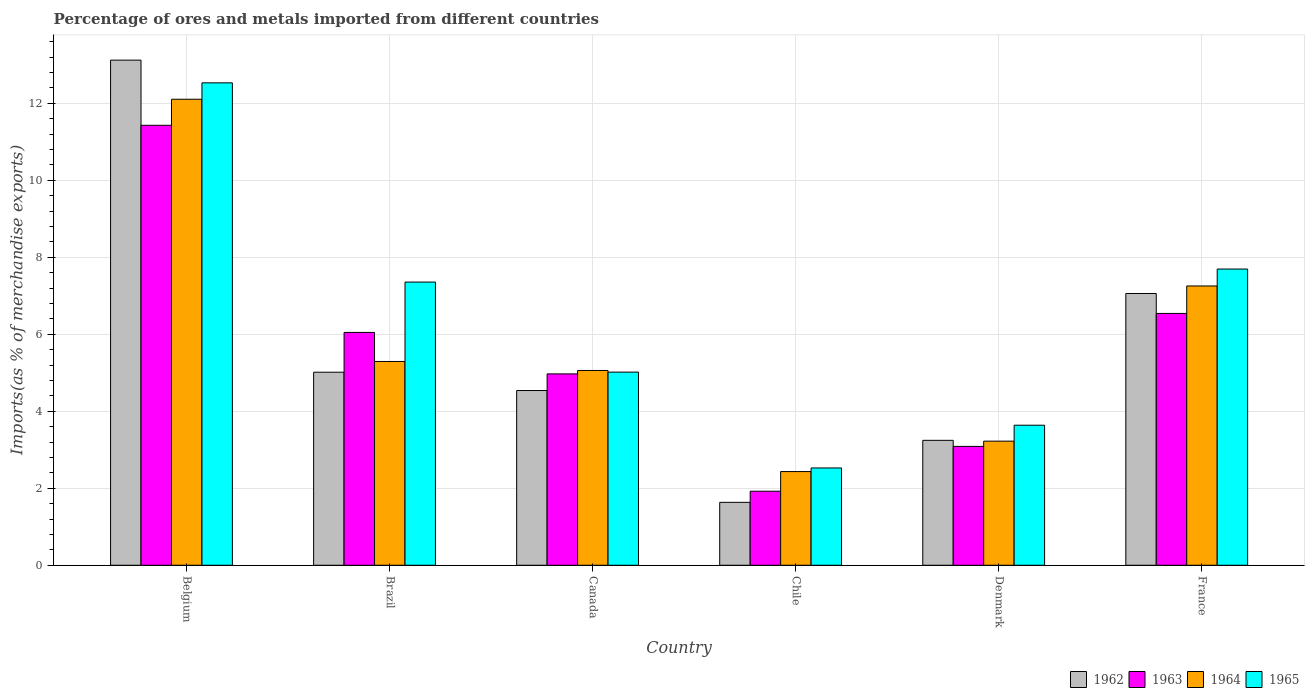How many different coloured bars are there?
Keep it short and to the point. 4. How many groups of bars are there?
Provide a succinct answer. 6. Are the number of bars on each tick of the X-axis equal?
Provide a succinct answer. Yes. How many bars are there on the 6th tick from the left?
Keep it short and to the point. 4. How many bars are there on the 1st tick from the right?
Offer a terse response. 4. What is the percentage of imports to different countries in 1964 in Canada?
Keep it short and to the point. 5.06. Across all countries, what is the maximum percentage of imports to different countries in 1962?
Provide a succinct answer. 13.12. Across all countries, what is the minimum percentage of imports to different countries in 1963?
Ensure brevity in your answer.  1.92. In which country was the percentage of imports to different countries in 1962 minimum?
Your answer should be very brief. Chile. What is the total percentage of imports to different countries in 1963 in the graph?
Keep it short and to the point. 34. What is the difference between the percentage of imports to different countries in 1964 in Brazil and that in France?
Your answer should be compact. -1.96. What is the difference between the percentage of imports to different countries in 1964 in France and the percentage of imports to different countries in 1963 in Chile?
Ensure brevity in your answer.  5.33. What is the average percentage of imports to different countries in 1963 per country?
Provide a short and direct response. 5.67. What is the difference between the percentage of imports to different countries of/in 1963 and percentage of imports to different countries of/in 1965 in Brazil?
Offer a very short reply. -1.31. In how many countries, is the percentage of imports to different countries in 1962 greater than 1.6 %?
Provide a short and direct response. 6. What is the ratio of the percentage of imports to different countries in 1964 in Belgium to that in Denmark?
Your answer should be compact. 3.75. Is the percentage of imports to different countries in 1962 in Belgium less than that in France?
Provide a succinct answer. No. What is the difference between the highest and the second highest percentage of imports to different countries in 1962?
Provide a succinct answer. -8.11. What is the difference between the highest and the lowest percentage of imports to different countries in 1965?
Make the answer very short. 10. In how many countries, is the percentage of imports to different countries in 1965 greater than the average percentage of imports to different countries in 1965 taken over all countries?
Ensure brevity in your answer.  3. Is it the case that in every country, the sum of the percentage of imports to different countries in 1963 and percentage of imports to different countries in 1962 is greater than the sum of percentage of imports to different countries in 1964 and percentage of imports to different countries in 1965?
Provide a short and direct response. No. What does the 1st bar from the left in Chile represents?
Your answer should be very brief. 1962. What does the 1st bar from the right in Chile represents?
Your answer should be very brief. 1965. Is it the case that in every country, the sum of the percentage of imports to different countries in 1964 and percentage of imports to different countries in 1965 is greater than the percentage of imports to different countries in 1962?
Give a very brief answer. Yes. How many bars are there?
Your answer should be compact. 24. How many countries are there in the graph?
Offer a terse response. 6. What is the difference between two consecutive major ticks on the Y-axis?
Offer a very short reply. 2. Does the graph contain any zero values?
Offer a very short reply. No. Does the graph contain grids?
Your answer should be compact. Yes. Where does the legend appear in the graph?
Offer a terse response. Bottom right. How many legend labels are there?
Ensure brevity in your answer.  4. What is the title of the graph?
Give a very brief answer. Percentage of ores and metals imported from different countries. Does "1986" appear as one of the legend labels in the graph?
Your response must be concise. No. What is the label or title of the X-axis?
Offer a terse response. Country. What is the label or title of the Y-axis?
Offer a very short reply. Imports(as % of merchandise exports). What is the Imports(as % of merchandise exports) of 1962 in Belgium?
Offer a very short reply. 13.12. What is the Imports(as % of merchandise exports) in 1963 in Belgium?
Your response must be concise. 11.43. What is the Imports(as % of merchandise exports) of 1964 in Belgium?
Your answer should be compact. 12.11. What is the Imports(as % of merchandise exports) in 1965 in Belgium?
Make the answer very short. 12.53. What is the Imports(as % of merchandise exports) of 1962 in Brazil?
Provide a short and direct response. 5.01. What is the Imports(as % of merchandise exports) of 1963 in Brazil?
Provide a succinct answer. 6.05. What is the Imports(as % of merchandise exports) in 1964 in Brazil?
Ensure brevity in your answer.  5.29. What is the Imports(as % of merchandise exports) of 1965 in Brazil?
Provide a succinct answer. 7.36. What is the Imports(as % of merchandise exports) of 1962 in Canada?
Your response must be concise. 4.54. What is the Imports(as % of merchandise exports) in 1963 in Canada?
Keep it short and to the point. 4.97. What is the Imports(as % of merchandise exports) in 1964 in Canada?
Your answer should be very brief. 5.06. What is the Imports(as % of merchandise exports) of 1965 in Canada?
Make the answer very short. 5.02. What is the Imports(as % of merchandise exports) in 1962 in Chile?
Your response must be concise. 1.63. What is the Imports(as % of merchandise exports) in 1963 in Chile?
Your answer should be very brief. 1.92. What is the Imports(as % of merchandise exports) of 1964 in Chile?
Ensure brevity in your answer.  2.43. What is the Imports(as % of merchandise exports) of 1965 in Chile?
Your response must be concise. 2.53. What is the Imports(as % of merchandise exports) in 1962 in Denmark?
Ensure brevity in your answer.  3.25. What is the Imports(as % of merchandise exports) of 1963 in Denmark?
Provide a succinct answer. 3.09. What is the Imports(as % of merchandise exports) in 1964 in Denmark?
Offer a terse response. 3.22. What is the Imports(as % of merchandise exports) in 1965 in Denmark?
Offer a terse response. 3.64. What is the Imports(as % of merchandise exports) of 1962 in France?
Make the answer very short. 7.06. What is the Imports(as % of merchandise exports) in 1963 in France?
Make the answer very short. 6.54. What is the Imports(as % of merchandise exports) of 1964 in France?
Give a very brief answer. 7.26. What is the Imports(as % of merchandise exports) in 1965 in France?
Your response must be concise. 7.7. Across all countries, what is the maximum Imports(as % of merchandise exports) in 1962?
Make the answer very short. 13.12. Across all countries, what is the maximum Imports(as % of merchandise exports) in 1963?
Provide a succinct answer. 11.43. Across all countries, what is the maximum Imports(as % of merchandise exports) in 1964?
Ensure brevity in your answer.  12.11. Across all countries, what is the maximum Imports(as % of merchandise exports) of 1965?
Provide a short and direct response. 12.53. Across all countries, what is the minimum Imports(as % of merchandise exports) of 1962?
Ensure brevity in your answer.  1.63. Across all countries, what is the minimum Imports(as % of merchandise exports) in 1963?
Give a very brief answer. 1.92. Across all countries, what is the minimum Imports(as % of merchandise exports) in 1964?
Provide a succinct answer. 2.43. Across all countries, what is the minimum Imports(as % of merchandise exports) of 1965?
Your answer should be compact. 2.53. What is the total Imports(as % of merchandise exports) of 1962 in the graph?
Keep it short and to the point. 34.62. What is the total Imports(as % of merchandise exports) in 1963 in the graph?
Give a very brief answer. 34. What is the total Imports(as % of merchandise exports) of 1964 in the graph?
Your answer should be compact. 35.37. What is the total Imports(as % of merchandise exports) in 1965 in the graph?
Keep it short and to the point. 38.77. What is the difference between the Imports(as % of merchandise exports) of 1962 in Belgium and that in Brazil?
Provide a short and direct response. 8.11. What is the difference between the Imports(as % of merchandise exports) of 1963 in Belgium and that in Brazil?
Your answer should be very brief. 5.38. What is the difference between the Imports(as % of merchandise exports) of 1964 in Belgium and that in Brazil?
Give a very brief answer. 6.81. What is the difference between the Imports(as % of merchandise exports) in 1965 in Belgium and that in Brazil?
Give a very brief answer. 5.18. What is the difference between the Imports(as % of merchandise exports) in 1962 in Belgium and that in Canada?
Your answer should be compact. 8.58. What is the difference between the Imports(as % of merchandise exports) of 1963 in Belgium and that in Canada?
Ensure brevity in your answer.  6.46. What is the difference between the Imports(as % of merchandise exports) of 1964 in Belgium and that in Canada?
Provide a short and direct response. 7.05. What is the difference between the Imports(as % of merchandise exports) of 1965 in Belgium and that in Canada?
Provide a short and direct response. 7.51. What is the difference between the Imports(as % of merchandise exports) in 1962 in Belgium and that in Chile?
Offer a terse response. 11.49. What is the difference between the Imports(as % of merchandise exports) in 1963 in Belgium and that in Chile?
Provide a succinct answer. 9.51. What is the difference between the Imports(as % of merchandise exports) of 1964 in Belgium and that in Chile?
Give a very brief answer. 9.67. What is the difference between the Imports(as % of merchandise exports) in 1965 in Belgium and that in Chile?
Keep it short and to the point. 10. What is the difference between the Imports(as % of merchandise exports) in 1962 in Belgium and that in Denmark?
Ensure brevity in your answer.  9.88. What is the difference between the Imports(as % of merchandise exports) of 1963 in Belgium and that in Denmark?
Provide a short and direct response. 8.34. What is the difference between the Imports(as % of merchandise exports) in 1964 in Belgium and that in Denmark?
Your response must be concise. 8.88. What is the difference between the Imports(as % of merchandise exports) in 1965 in Belgium and that in Denmark?
Your answer should be very brief. 8.89. What is the difference between the Imports(as % of merchandise exports) in 1962 in Belgium and that in France?
Offer a terse response. 6.06. What is the difference between the Imports(as % of merchandise exports) in 1963 in Belgium and that in France?
Give a very brief answer. 4.89. What is the difference between the Imports(as % of merchandise exports) of 1964 in Belgium and that in France?
Give a very brief answer. 4.85. What is the difference between the Imports(as % of merchandise exports) in 1965 in Belgium and that in France?
Your answer should be very brief. 4.84. What is the difference between the Imports(as % of merchandise exports) in 1962 in Brazil and that in Canada?
Keep it short and to the point. 0.48. What is the difference between the Imports(as % of merchandise exports) in 1963 in Brazil and that in Canada?
Provide a short and direct response. 1.08. What is the difference between the Imports(as % of merchandise exports) in 1964 in Brazil and that in Canada?
Provide a succinct answer. 0.23. What is the difference between the Imports(as % of merchandise exports) of 1965 in Brazil and that in Canada?
Keep it short and to the point. 2.34. What is the difference between the Imports(as % of merchandise exports) of 1962 in Brazil and that in Chile?
Provide a short and direct response. 3.38. What is the difference between the Imports(as % of merchandise exports) in 1963 in Brazil and that in Chile?
Make the answer very short. 4.12. What is the difference between the Imports(as % of merchandise exports) of 1964 in Brazil and that in Chile?
Provide a short and direct response. 2.86. What is the difference between the Imports(as % of merchandise exports) of 1965 in Brazil and that in Chile?
Make the answer very short. 4.83. What is the difference between the Imports(as % of merchandise exports) in 1962 in Brazil and that in Denmark?
Ensure brevity in your answer.  1.77. What is the difference between the Imports(as % of merchandise exports) of 1963 in Brazil and that in Denmark?
Keep it short and to the point. 2.96. What is the difference between the Imports(as % of merchandise exports) in 1964 in Brazil and that in Denmark?
Give a very brief answer. 2.07. What is the difference between the Imports(as % of merchandise exports) in 1965 in Brazil and that in Denmark?
Give a very brief answer. 3.72. What is the difference between the Imports(as % of merchandise exports) in 1962 in Brazil and that in France?
Keep it short and to the point. -2.05. What is the difference between the Imports(as % of merchandise exports) in 1963 in Brazil and that in France?
Offer a very short reply. -0.49. What is the difference between the Imports(as % of merchandise exports) in 1964 in Brazil and that in France?
Your answer should be very brief. -1.96. What is the difference between the Imports(as % of merchandise exports) in 1965 in Brazil and that in France?
Your answer should be compact. -0.34. What is the difference between the Imports(as % of merchandise exports) of 1962 in Canada and that in Chile?
Provide a short and direct response. 2.9. What is the difference between the Imports(as % of merchandise exports) of 1963 in Canada and that in Chile?
Provide a succinct answer. 3.05. What is the difference between the Imports(as % of merchandise exports) of 1964 in Canada and that in Chile?
Your answer should be very brief. 2.63. What is the difference between the Imports(as % of merchandise exports) of 1965 in Canada and that in Chile?
Ensure brevity in your answer.  2.49. What is the difference between the Imports(as % of merchandise exports) of 1962 in Canada and that in Denmark?
Your answer should be very brief. 1.29. What is the difference between the Imports(as % of merchandise exports) in 1963 in Canada and that in Denmark?
Provide a succinct answer. 1.88. What is the difference between the Imports(as % of merchandise exports) of 1964 in Canada and that in Denmark?
Offer a very short reply. 1.84. What is the difference between the Imports(as % of merchandise exports) of 1965 in Canada and that in Denmark?
Provide a succinct answer. 1.38. What is the difference between the Imports(as % of merchandise exports) of 1962 in Canada and that in France?
Provide a short and direct response. -2.52. What is the difference between the Imports(as % of merchandise exports) of 1963 in Canada and that in France?
Keep it short and to the point. -1.57. What is the difference between the Imports(as % of merchandise exports) of 1964 in Canada and that in France?
Your response must be concise. -2.19. What is the difference between the Imports(as % of merchandise exports) in 1965 in Canada and that in France?
Give a very brief answer. -2.68. What is the difference between the Imports(as % of merchandise exports) of 1962 in Chile and that in Denmark?
Keep it short and to the point. -1.61. What is the difference between the Imports(as % of merchandise exports) in 1963 in Chile and that in Denmark?
Offer a very short reply. -1.16. What is the difference between the Imports(as % of merchandise exports) of 1964 in Chile and that in Denmark?
Your answer should be compact. -0.79. What is the difference between the Imports(as % of merchandise exports) of 1965 in Chile and that in Denmark?
Keep it short and to the point. -1.11. What is the difference between the Imports(as % of merchandise exports) of 1962 in Chile and that in France?
Ensure brevity in your answer.  -5.43. What is the difference between the Imports(as % of merchandise exports) in 1963 in Chile and that in France?
Provide a succinct answer. -4.62. What is the difference between the Imports(as % of merchandise exports) of 1964 in Chile and that in France?
Offer a terse response. -4.82. What is the difference between the Imports(as % of merchandise exports) of 1965 in Chile and that in France?
Your response must be concise. -5.17. What is the difference between the Imports(as % of merchandise exports) of 1962 in Denmark and that in France?
Your answer should be very brief. -3.81. What is the difference between the Imports(as % of merchandise exports) in 1963 in Denmark and that in France?
Make the answer very short. -3.45. What is the difference between the Imports(as % of merchandise exports) in 1964 in Denmark and that in France?
Make the answer very short. -4.03. What is the difference between the Imports(as % of merchandise exports) of 1965 in Denmark and that in France?
Your answer should be very brief. -4.06. What is the difference between the Imports(as % of merchandise exports) of 1962 in Belgium and the Imports(as % of merchandise exports) of 1963 in Brazil?
Ensure brevity in your answer.  7.07. What is the difference between the Imports(as % of merchandise exports) of 1962 in Belgium and the Imports(as % of merchandise exports) of 1964 in Brazil?
Give a very brief answer. 7.83. What is the difference between the Imports(as % of merchandise exports) of 1962 in Belgium and the Imports(as % of merchandise exports) of 1965 in Brazil?
Make the answer very short. 5.77. What is the difference between the Imports(as % of merchandise exports) in 1963 in Belgium and the Imports(as % of merchandise exports) in 1964 in Brazil?
Your answer should be compact. 6.14. What is the difference between the Imports(as % of merchandise exports) in 1963 in Belgium and the Imports(as % of merchandise exports) in 1965 in Brazil?
Make the answer very short. 4.07. What is the difference between the Imports(as % of merchandise exports) of 1964 in Belgium and the Imports(as % of merchandise exports) of 1965 in Brazil?
Make the answer very short. 4.75. What is the difference between the Imports(as % of merchandise exports) of 1962 in Belgium and the Imports(as % of merchandise exports) of 1963 in Canada?
Your response must be concise. 8.15. What is the difference between the Imports(as % of merchandise exports) in 1962 in Belgium and the Imports(as % of merchandise exports) in 1964 in Canada?
Provide a succinct answer. 8.06. What is the difference between the Imports(as % of merchandise exports) of 1962 in Belgium and the Imports(as % of merchandise exports) of 1965 in Canada?
Ensure brevity in your answer.  8.1. What is the difference between the Imports(as % of merchandise exports) of 1963 in Belgium and the Imports(as % of merchandise exports) of 1964 in Canada?
Provide a short and direct response. 6.37. What is the difference between the Imports(as % of merchandise exports) in 1963 in Belgium and the Imports(as % of merchandise exports) in 1965 in Canada?
Your response must be concise. 6.41. What is the difference between the Imports(as % of merchandise exports) of 1964 in Belgium and the Imports(as % of merchandise exports) of 1965 in Canada?
Keep it short and to the point. 7.09. What is the difference between the Imports(as % of merchandise exports) in 1962 in Belgium and the Imports(as % of merchandise exports) in 1963 in Chile?
Make the answer very short. 11.2. What is the difference between the Imports(as % of merchandise exports) of 1962 in Belgium and the Imports(as % of merchandise exports) of 1964 in Chile?
Your answer should be very brief. 10.69. What is the difference between the Imports(as % of merchandise exports) of 1962 in Belgium and the Imports(as % of merchandise exports) of 1965 in Chile?
Give a very brief answer. 10.59. What is the difference between the Imports(as % of merchandise exports) in 1963 in Belgium and the Imports(as % of merchandise exports) in 1964 in Chile?
Ensure brevity in your answer.  9. What is the difference between the Imports(as % of merchandise exports) in 1963 in Belgium and the Imports(as % of merchandise exports) in 1965 in Chile?
Provide a succinct answer. 8.9. What is the difference between the Imports(as % of merchandise exports) of 1964 in Belgium and the Imports(as % of merchandise exports) of 1965 in Chile?
Your response must be concise. 9.58. What is the difference between the Imports(as % of merchandise exports) in 1962 in Belgium and the Imports(as % of merchandise exports) in 1963 in Denmark?
Your response must be concise. 10.03. What is the difference between the Imports(as % of merchandise exports) of 1962 in Belgium and the Imports(as % of merchandise exports) of 1964 in Denmark?
Provide a succinct answer. 9.9. What is the difference between the Imports(as % of merchandise exports) in 1962 in Belgium and the Imports(as % of merchandise exports) in 1965 in Denmark?
Give a very brief answer. 9.48. What is the difference between the Imports(as % of merchandise exports) of 1963 in Belgium and the Imports(as % of merchandise exports) of 1964 in Denmark?
Give a very brief answer. 8.21. What is the difference between the Imports(as % of merchandise exports) of 1963 in Belgium and the Imports(as % of merchandise exports) of 1965 in Denmark?
Offer a terse response. 7.79. What is the difference between the Imports(as % of merchandise exports) of 1964 in Belgium and the Imports(as % of merchandise exports) of 1965 in Denmark?
Your response must be concise. 8.47. What is the difference between the Imports(as % of merchandise exports) of 1962 in Belgium and the Imports(as % of merchandise exports) of 1963 in France?
Ensure brevity in your answer.  6.58. What is the difference between the Imports(as % of merchandise exports) in 1962 in Belgium and the Imports(as % of merchandise exports) in 1964 in France?
Give a very brief answer. 5.87. What is the difference between the Imports(as % of merchandise exports) of 1962 in Belgium and the Imports(as % of merchandise exports) of 1965 in France?
Make the answer very short. 5.43. What is the difference between the Imports(as % of merchandise exports) of 1963 in Belgium and the Imports(as % of merchandise exports) of 1964 in France?
Ensure brevity in your answer.  4.17. What is the difference between the Imports(as % of merchandise exports) of 1963 in Belgium and the Imports(as % of merchandise exports) of 1965 in France?
Ensure brevity in your answer.  3.73. What is the difference between the Imports(as % of merchandise exports) of 1964 in Belgium and the Imports(as % of merchandise exports) of 1965 in France?
Keep it short and to the point. 4.41. What is the difference between the Imports(as % of merchandise exports) in 1962 in Brazil and the Imports(as % of merchandise exports) in 1963 in Canada?
Ensure brevity in your answer.  0.04. What is the difference between the Imports(as % of merchandise exports) of 1962 in Brazil and the Imports(as % of merchandise exports) of 1964 in Canada?
Offer a very short reply. -0.05. What is the difference between the Imports(as % of merchandise exports) in 1962 in Brazil and the Imports(as % of merchandise exports) in 1965 in Canada?
Make the answer very short. -0. What is the difference between the Imports(as % of merchandise exports) in 1963 in Brazil and the Imports(as % of merchandise exports) in 1964 in Canada?
Your response must be concise. 0.99. What is the difference between the Imports(as % of merchandise exports) of 1963 in Brazil and the Imports(as % of merchandise exports) of 1965 in Canada?
Provide a short and direct response. 1.03. What is the difference between the Imports(as % of merchandise exports) of 1964 in Brazil and the Imports(as % of merchandise exports) of 1965 in Canada?
Your answer should be very brief. 0.28. What is the difference between the Imports(as % of merchandise exports) in 1962 in Brazil and the Imports(as % of merchandise exports) in 1963 in Chile?
Ensure brevity in your answer.  3.09. What is the difference between the Imports(as % of merchandise exports) of 1962 in Brazil and the Imports(as % of merchandise exports) of 1964 in Chile?
Ensure brevity in your answer.  2.58. What is the difference between the Imports(as % of merchandise exports) of 1962 in Brazil and the Imports(as % of merchandise exports) of 1965 in Chile?
Offer a very short reply. 2.49. What is the difference between the Imports(as % of merchandise exports) in 1963 in Brazil and the Imports(as % of merchandise exports) in 1964 in Chile?
Your response must be concise. 3.61. What is the difference between the Imports(as % of merchandise exports) of 1963 in Brazil and the Imports(as % of merchandise exports) of 1965 in Chile?
Provide a succinct answer. 3.52. What is the difference between the Imports(as % of merchandise exports) in 1964 in Brazil and the Imports(as % of merchandise exports) in 1965 in Chile?
Give a very brief answer. 2.77. What is the difference between the Imports(as % of merchandise exports) in 1962 in Brazil and the Imports(as % of merchandise exports) in 1963 in Denmark?
Make the answer very short. 1.93. What is the difference between the Imports(as % of merchandise exports) of 1962 in Brazil and the Imports(as % of merchandise exports) of 1964 in Denmark?
Your answer should be very brief. 1.79. What is the difference between the Imports(as % of merchandise exports) of 1962 in Brazil and the Imports(as % of merchandise exports) of 1965 in Denmark?
Keep it short and to the point. 1.38. What is the difference between the Imports(as % of merchandise exports) in 1963 in Brazil and the Imports(as % of merchandise exports) in 1964 in Denmark?
Your answer should be compact. 2.82. What is the difference between the Imports(as % of merchandise exports) in 1963 in Brazil and the Imports(as % of merchandise exports) in 1965 in Denmark?
Keep it short and to the point. 2.41. What is the difference between the Imports(as % of merchandise exports) in 1964 in Brazil and the Imports(as % of merchandise exports) in 1965 in Denmark?
Your answer should be compact. 1.66. What is the difference between the Imports(as % of merchandise exports) in 1962 in Brazil and the Imports(as % of merchandise exports) in 1963 in France?
Give a very brief answer. -1.53. What is the difference between the Imports(as % of merchandise exports) of 1962 in Brazil and the Imports(as % of merchandise exports) of 1964 in France?
Your answer should be very brief. -2.24. What is the difference between the Imports(as % of merchandise exports) of 1962 in Brazil and the Imports(as % of merchandise exports) of 1965 in France?
Offer a terse response. -2.68. What is the difference between the Imports(as % of merchandise exports) of 1963 in Brazil and the Imports(as % of merchandise exports) of 1964 in France?
Make the answer very short. -1.21. What is the difference between the Imports(as % of merchandise exports) in 1963 in Brazil and the Imports(as % of merchandise exports) in 1965 in France?
Provide a succinct answer. -1.65. What is the difference between the Imports(as % of merchandise exports) of 1964 in Brazil and the Imports(as % of merchandise exports) of 1965 in France?
Provide a succinct answer. -2.4. What is the difference between the Imports(as % of merchandise exports) in 1962 in Canada and the Imports(as % of merchandise exports) in 1963 in Chile?
Give a very brief answer. 2.62. What is the difference between the Imports(as % of merchandise exports) in 1962 in Canada and the Imports(as % of merchandise exports) in 1964 in Chile?
Make the answer very short. 2.11. What is the difference between the Imports(as % of merchandise exports) in 1962 in Canada and the Imports(as % of merchandise exports) in 1965 in Chile?
Your answer should be very brief. 2.01. What is the difference between the Imports(as % of merchandise exports) in 1963 in Canada and the Imports(as % of merchandise exports) in 1964 in Chile?
Provide a short and direct response. 2.54. What is the difference between the Imports(as % of merchandise exports) of 1963 in Canada and the Imports(as % of merchandise exports) of 1965 in Chile?
Ensure brevity in your answer.  2.44. What is the difference between the Imports(as % of merchandise exports) of 1964 in Canada and the Imports(as % of merchandise exports) of 1965 in Chile?
Your response must be concise. 2.53. What is the difference between the Imports(as % of merchandise exports) of 1962 in Canada and the Imports(as % of merchandise exports) of 1963 in Denmark?
Your answer should be compact. 1.45. What is the difference between the Imports(as % of merchandise exports) of 1962 in Canada and the Imports(as % of merchandise exports) of 1964 in Denmark?
Your response must be concise. 1.31. What is the difference between the Imports(as % of merchandise exports) of 1962 in Canada and the Imports(as % of merchandise exports) of 1965 in Denmark?
Your response must be concise. 0.9. What is the difference between the Imports(as % of merchandise exports) of 1963 in Canada and the Imports(as % of merchandise exports) of 1964 in Denmark?
Provide a succinct answer. 1.75. What is the difference between the Imports(as % of merchandise exports) of 1963 in Canada and the Imports(as % of merchandise exports) of 1965 in Denmark?
Make the answer very short. 1.33. What is the difference between the Imports(as % of merchandise exports) in 1964 in Canada and the Imports(as % of merchandise exports) in 1965 in Denmark?
Keep it short and to the point. 1.42. What is the difference between the Imports(as % of merchandise exports) of 1962 in Canada and the Imports(as % of merchandise exports) of 1963 in France?
Ensure brevity in your answer.  -2. What is the difference between the Imports(as % of merchandise exports) in 1962 in Canada and the Imports(as % of merchandise exports) in 1964 in France?
Your answer should be compact. -2.72. What is the difference between the Imports(as % of merchandise exports) in 1962 in Canada and the Imports(as % of merchandise exports) in 1965 in France?
Your answer should be compact. -3.16. What is the difference between the Imports(as % of merchandise exports) of 1963 in Canada and the Imports(as % of merchandise exports) of 1964 in France?
Your answer should be compact. -2.28. What is the difference between the Imports(as % of merchandise exports) in 1963 in Canada and the Imports(as % of merchandise exports) in 1965 in France?
Keep it short and to the point. -2.72. What is the difference between the Imports(as % of merchandise exports) of 1964 in Canada and the Imports(as % of merchandise exports) of 1965 in France?
Your response must be concise. -2.64. What is the difference between the Imports(as % of merchandise exports) in 1962 in Chile and the Imports(as % of merchandise exports) in 1963 in Denmark?
Ensure brevity in your answer.  -1.45. What is the difference between the Imports(as % of merchandise exports) of 1962 in Chile and the Imports(as % of merchandise exports) of 1964 in Denmark?
Ensure brevity in your answer.  -1.59. What is the difference between the Imports(as % of merchandise exports) in 1962 in Chile and the Imports(as % of merchandise exports) in 1965 in Denmark?
Your answer should be very brief. -2. What is the difference between the Imports(as % of merchandise exports) in 1963 in Chile and the Imports(as % of merchandise exports) in 1964 in Denmark?
Keep it short and to the point. -1.3. What is the difference between the Imports(as % of merchandise exports) of 1963 in Chile and the Imports(as % of merchandise exports) of 1965 in Denmark?
Offer a very short reply. -1.71. What is the difference between the Imports(as % of merchandise exports) in 1964 in Chile and the Imports(as % of merchandise exports) in 1965 in Denmark?
Give a very brief answer. -1.2. What is the difference between the Imports(as % of merchandise exports) of 1962 in Chile and the Imports(as % of merchandise exports) of 1963 in France?
Make the answer very short. -4.91. What is the difference between the Imports(as % of merchandise exports) in 1962 in Chile and the Imports(as % of merchandise exports) in 1964 in France?
Provide a short and direct response. -5.62. What is the difference between the Imports(as % of merchandise exports) in 1962 in Chile and the Imports(as % of merchandise exports) in 1965 in France?
Keep it short and to the point. -6.06. What is the difference between the Imports(as % of merchandise exports) of 1963 in Chile and the Imports(as % of merchandise exports) of 1964 in France?
Your answer should be very brief. -5.33. What is the difference between the Imports(as % of merchandise exports) in 1963 in Chile and the Imports(as % of merchandise exports) in 1965 in France?
Your answer should be very brief. -5.77. What is the difference between the Imports(as % of merchandise exports) in 1964 in Chile and the Imports(as % of merchandise exports) in 1965 in France?
Your response must be concise. -5.26. What is the difference between the Imports(as % of merchandise exports) in 1962 in Denmark and the Imports(as % of merchandise exports) in 1963 in France?
Make the answer very short. -3.3. What is the difference between the Imports(as % of merchandise exports) of 1962 in Denmark and the Imports(as % of merchandise exports) of 1964 in France?
Give a very brief answer. -4.01. What is the difference between the Imports(as % of merchandise exports) of 1962 in Denmark and the Imports(as % of merchandise exports) of 1965 in France?
Provide a succinct answer. -4.45. What is the difference between the Imports(as % of merchandise exports) in 1963 in Denmark and the Imports(as % of merchandise exports) in 1964 in France?
Give a very brief answer. -4.17. What is the difference between the Imports(as % of merchandise exports) in 1963 in Denmark and the Imports(as % of merchandise exports) in 1965 in France?
Your response must be concise. -4.61. What is the difference between the Imports(as % of merchandise exports) of 1964 in Denmark and the Imports(as % of merchandise exports) of 1965 in France?
Your answer should be compact. -4.47. What is the average Imports(as % of merchandise exports) of 1962 per country?
Offer a very short reply. 5.77. What is the average Imports(as % of merchandise exports) of 1963 per country?
Keep it short and to the point. 5.67. What is the average Imports(as % of merchandise exports) of 1964 per country?
Your answer should be very brief. 5.9. What is the average Imports(as % of merchandise exports) in 1965 per country?
Provide a short and direct response. 6.46. What is the difference between the Imports(as % of merchandise exports) of 1962 and Imports(as % of merchandise exports) of 1963 in Belgium?
Give a very brief answer. 1.69. What is the difference between the Imports(as % of merchandise exports) of 1962 and Imports(as % of merchandise exports) of 1964 in Belgium?
Offer a very short reply. 1.02. What is the difference between the Imports(as % of merchandise exports) in 1962 and Imports(as % of merchandise exports) in 1965 in Belgium?
Offer a terse response. 0.59. What is the difference between the Imports(as % of merchandise exports) of 1963 and Imports(as % of merchandise exports) of 1964 in Belgium?
Ensure brevity in your answer.  -0.68. What is the difference between the Imports(as % of merchandise exports) in 1963 and Imports(as % of merchandise exports) in 1965 in Belgium?
Give a very brief answer. -1.1. What is the difference between the Imports(as % of merchandise exports) in 1964 and Imports(as % of merchandise exports) in 1965 in Belgium?
Your answer should be compact. -0.43. What is the difference between the Imports(as % of merchandise exports) of 1962 and Imports(as % of merchandise exports) of 1963 in Brazil?
Provide a short and direct response. -1.03. What is the difference between the Imports(as % of merchandise exports) of 1962 and Imports(as % of merchandise exports) of 1964 in Brazil?
Your response must be concise. -0.28. What is the difference between the Imports(as % of merchandise exports) of 1962 and Imports(as % of merchandise exports) of 1965 in Brazil?
Keep it short and to the point. -2.34. What is the difference between the Imports(as % of merchandise exports) in 1963 and Imports(as % of merchandise exports) in 1964 in Brazil?
Give a very brief answer. 0.75. What is the difference between the Imports(as % of merchandise exports) of 1963 and Imports(as % of merchandise exports) of 1965 in Brazil?
Offer a terse response. -1.31. What is the difference between the Imports(as % of merchandise exports) in 1964 and Imports(as % of merchandise exports) in 1965 in Brazil?
Offer a terse response. -2.06. What is the difference between the Imports(as % of merchandise exports) of 1962 and Imports(as % of merchandise exports) of 1963 in Canada?
Your answer should be compact. -0.43. What is the difference between the Imports(as % of merchandise exports) in 1962 and Imports(as % of merchandise exports) in 1964 in Canada?
Give a very brief answer. -0.52. What is the difference between the Imports(as % of merchandise exports) of 1962 and Imports(as % of merchandise exports) of 1965 in Canada?
Offer a terse response. -0.48. What is the difference between the Imports(as % of merchandise exports) of 1963 and Imports(as % of merchandise exports) of 1964 in Canada?
Provide a short and direct response. -0.09. What is the difference between the Imports(as % of merchandise exports) in 1963 and Imports(as % of merchandise exports) in 1965 in Canada?
Your answer should be very brief. -0.05. What is the difference between the Imports(as % of merchandise exports) of 1964 and Imports(as % of merchandise exports) of 1965 in Canada?
Your response must be concise. 0.04. What is the difference between the Imports(as % of merchandise exports) of 1962 and Imports(as % of merchandise exports) of 1963 in Chile?
Your answer should be compact. -0.29. What is the difference between the Imports(as % of merchandise exports) in 1962 and Imports(as % of merchandise exports) in 1964 in Chile?
Your answer should be very brief. -0.8. What is the difference between the Imports(as % of merchandise exports) in 1962 and Imports(as % of merchandise exports) in 1965 in Chile?
Make the answer very short. -0.89. What is the difference between the Imports(as % of merchandise exports) of 1963 and Imports(as % of merchandise exports) of 1964 in Chile?
Ensure brevity in your answer.  -0.51. What is the difference between the Imports(as % of merchandise exports) in 1963 and Imports(as % of merchandise exports) in 1965 in Chile?
Make the answer very short. -0.6. What is the difference between the Imports(as % of merchandise exports) in 1964 and Imports(as % of merchandise exports) in 1965 in Chile?
Give a very brief answer. -0.09. What is the difference between the Imports(as % of merchandise exports) in 1962 and Imports(as % of merchandise exports) in 1963 in Denmark?
Offer a terse response. 0.16. What is the difference between the Imports(as % of merchandise exports) of 1962 and Imports(as % of merchandise exports) of 1964 in Denmark?
Ensure brevity in your answer.  0.02. What is the difference between the Imports(as % of merchandise exports) in 1962 and Imports(as % of merchandise exports) in 1965 in Denmark?
Provide a succinct answer. -0.39. What is the difference between the Imports(as % of merchandise exports) of 1963 and Imports(as % of merchandise exports) of 1964 in Denmark?
Provide a short and direct response. -0.14. What is the difference between the Imports(as % of merchandise exports) in 1963 and Imports(as % of merchandise exports) in 1965 in Denmark?
Keep it short and to the point. -0.55. What is the difference between the Imports(as % of merchandise exports) of 1964 and Imports(as % of merchandise exports) of 1965 in Denmark?
Keep it short and to the point. -0.41. What is the difference between the Imports(as % of merchandise exports) of 1962 and Imports(as % of merchandise exports) of 1963 in France?
Your response must be concise. 0.52. What is the difference between the Imports(as % of merchandise exports) of 1962 and Imports(as % of merchandise exports) of 1964 in France?
Your response must be concise. -0.2. What is the difference between the Imports(as % of merchandise exports) in 1962 and Imports(as % of merchandise exports) in 1965 in France?
Make the answer very short. -0.64. What is the difference between the Imports(as % of merchandise exports) of 1963 and Imports(as % of merchandise exports) of 1964 in France?
Your answer should be compact. -0.71. What is the difference between the Imports(as % of merchandise exports) in 1963 and Imports(as % of merchandise exports) in 1965 in France?
Offer a very short reply. -1.15. What is the difference between the Imports(as % of merchandise exports) in 1964 and Imports(as % of merchandise exports) in 1965 in France?
Give a very brief answer. -0.44. What is the ratio of the Imports(as % of merchandise exports) in 1962 in Belgium to that in Brazil?
Your response must be concise. 2.62. What is the ratio of the Imports(as % of merchandise exports) in 1963 in Belgium to that in Brazil?
Ensure brevity in your answer.  1.89. What is the ratio of the Imports(as % of merchandise exports) in 1964 in Belgium to that in Brazil?
Ensure brevity in your answer.  2.29. What is the ratio of the Imports(as % of merchandise exports) of 1965 in Belgium to that in Brazil?
Offer a terse response. 1.7. What is the ratio of the Imports(as % of merchandise exports) in 1962 in Belgium to that in Canada?
Give a very brief answer. 2.89. What is the ratio of the Imports(as % of merchandise exports) of 1963 in Belgium to that in Canada?
Make the answer very short. 2.3. What is the ratio of the Imports(as % of merchandise exports) of 1964 in Belgium to that in Canada?
Ensure brevity in your answer.  2.39. What is the ratio of the Imports(as % of merchandise exports) in 1965 in Belgium to that in Canada?
Your answer should be compact. 2.5. What is the ratio of the Imports(as % of merchandise exports) in 1962 in Belgium to that in Chile?
Offer a very short reply. 8.03. What is the ratio of the Imports(as % of merchandise exports) of 1963 in Belgium to that in Chile?
Provide a short and direct response. 5.94. What is the ratio of the Imports(as % of merchandise exports) of 1964 in Belgium to that in Chile?
Make the answer very short. 4.97. What is the ratio of the Imports(as % of merchandise exports) of 1965 in Belgium to that in Chile?
Provide a succinct answer. 4.96. What is the ratio of the Imports(as % of merchandise exports) in 1962 in Belgium to that in Denmark?
Your answer should be very brief. 4.04. What is the ratio of the Imports(as % of merchandise exports) of 1963 in Belgium to that in Denmark?
Keep it short and to the point. 3.7. What is the ratio of the Imports(as % of merchandise exports) of 1964 in Belgium to that in Denmark?
Provide a succinct answer. 3.75. What is the ratio of the Imports(as % of merchandise exports) in 1965 in Belgium to that in Denmark?
Your answer should be very brief. 3.44. What is the ratio of the Imports(as % of merchandise exports) of 1962 in Belgium to that in France?
Give a very brief answer. 1.86. What is the ratio of the Imports(as % of merchandise exports) of 1963 in Belgium to that in France?
Your answer should be compact. 1.75. What is the ratio of the Imports(as % of merchandise exports) of 1964 in Belgium to that in France?
Ensure brevity in your answer.  1.67. What is the ratio of the Imports(as % of merchandise exports) of 1965 in Belgium to that in France?
Your response must be concise. 1.63. What is the ratio of the Imports(as % of merchandise exports) in 1962 in Brazil to that in Canada?
Give a very brief answer. 1.1. What is the ratio of the Imports(as % of merchandise exports) in 1963 in Brazil to that in Canada?
Provide a succinct answer. 1.22. What is the ratio of the Imports(as % of merchandise exports) of 1964 in Brazil to that in Canada?
Your answer should be very brief. 1.05. What is the ratio of the Imports(as % of merchandise exports) of 1965 in Brazil to that in Canada?
Provide a short and direct response. 1.47. What is the ratio of the Imports(as % of merchandise exports) of 1962 in Brazil to that in Chile?
Offer a very short reply. 3.07. What is the ratio of the Imports(as % of merchandise exports) in 1963 in Brazil to that in Chile?
Give a very brief answer. 3.14. What is the ratio of the Imports(as % of merchandise exports) of 1964 in Brazil to that in Chile?
Provide a succinct answer. 2.18. What is the ratio of the Imports(as % of merchandise exports) of 1965 in Brazil to that in Chile?
Ensure brevity in your answer.  2.91. What is the ratio of the Imports(as % of merchandise exports) in 1962 in Brazil to that in Denmark?
Offer a very short reply. 1.55. What is the ratio of the Imports(as % of merchandise exports) of 1963 in Brazil to that in Denmark?
Give a very brief answer. 1.96. What is the ratio of the Imports(as % of merchandise exports) of 1964 in Brazil to that in Denmark?
Give a very brief answer. 1.64. What is the ratio of the Imports(as % of merchandise exports) of 1965 in Brazil to that in Denmark?
Keep it short and to the point. 2.02. What is the ratio of the Imports(as % of merchandise exports) of 1962 in Brazil to that in France?
Keep it short and to the point. 0.71. What is the ratio of the Imports(as % of merchandise exports) in 1963 in Brazil to that in France?
Keep it short and to the point. 0.92. What is the ratio of the Imports(as % of merchandise exports) in 1964 in Brazil to that in France?
Offer a very short reply. 0.73. What is the ratio of the Imports(as % of merchandise exports) of 1965 in Brazil to that in France?
Your answer should be very brief. 0.96. What is the ratio of the Imports(as % of merchandise exports) in 1962 in Canada to that in Chile?
Your response must be concise. 2.78. What is the ratio of the Imports(as % of merchandise exports) in 1963 in Canada to that in Chile?
Offer a terse response. 2.58. What is the ratio of the Imports(as % of merchandise exports) of 1964 in Canada to that in Chile?
Keep it short and to the point. 2.08. What is the ratio of the Imports(as % of merchandise exports) of 1965 in Canada to that in Chile?
Keep it short and to the point. 1.99. What is the ratio of the Imports(as % of merchandise exports) of 1962 in Canada to that in Denmark?
Offer a terse response. 1.4. What is the ratio of the Imports(as % of merchandise exports) of 1963 in Canada to that in Denmark?
Offer a terse response. 1.61. What is the ratio of the Imports(as % of merchandise exports) in 1964 in Canada to that in Denmark?
Give a very brief answer. 1.57. What is the ratio of the Imports(as % of merchandise exports) of 1965 in Canada to that in Denmark?
Provide a succinct answer. 1.38. What is the ratio of the Imports(as % of merchandise exports) in 1962 in Canada to that in France?
Offer a terse response. 0.64. What is the ratio of the Imports(as % of merchandise exports) in 1963 in Canada to that in France?
Provide a short and direct response. 0.76. What is the ratio of the Imports(as % of merchandise exports) in 1964 in Canada to that in France?
Offer a terse response. 0.7. What is the ratio of the Imports(as % of merchandise exports) in 1965 in Canada to that in France?
Offer a terse response. 0.65. What is the ratio of the Imports(as % of merchandise exports) in 1962 in Chile to that in Denmark?
Your response must be concise. 0.5. What is the ratio of the Imports(as % of merchandise exports) in 1963 in Chile to that in Denmark?
Offer a very short reply. 0.62. What is the ratio of the Imports(as % of merchandise exports) of 1964 in Chile to that in Denmark?
Your response must be concise. 0.75. What is the ratio of the Imports(as % of merchandise exports) of 1965 in Chile to that in Denmark?
Ensure brevity in your answer.  0.69. What is the ratio of the Imports(as % of merchandise exports) of 1962 in Chile to that in France?
Provide a succinct answer. 0.23. What is the ratio of the Imports(as % of merchandise exports) of 1963 in Chile to that in France?
Keep it short and to the point. 0.29. What is the ratio of the Imports(as % of merchandise exports) in 1964 in Chile to that in France?
Ensure brevity in your answer.  0.34. What is the ratio of the Imports(as % of merchandise exports) of 1965 in Chile to that in France?
Your answer should be compact. 0.33. What is the ratio of the Imports(as % of merchandise exports) of 1962 in Denmark to that in France?
Your answer should be compact. 0.46. What is the ratio of the Imports(as % of merchandise exports) of 1963 in Denmark to that in France?
Offer a very short reply. 0.47. What is the ratio of the Imports(as % of merchandise exports) of 1964 in Denmark to that in France?
Offer a terse response. 0.44. What is the ratio of the Imports(as % of merchandise exports) of 1965 in Denmark to that in France?
Ensure brevity in your answer.  0.47. What is the difference between the highest and the second highest Imports(as % of merchandise exports) of 1962?
Offer a very short reply. 6.06. What is the difference between the highest and the second highest Imports(as % of merchandise exports) in 1963?
Keep it short and to the point. 4.89. What is the difference between the highest and the second highest Imports(as % of merchandise exports) in 1964?
Provide a succinct answer. 4.85. What is the difference between the highest and the second highest Imports(as % of merchandise exports) in 1965?
Your answer should be compact. 4.84. What is the difference between the highest and the lowest Imports(as % of merchandise exports) in 1962?
Your answer should be compact. 11.49. What is the difference between the highest and the lowest Imports(as % of merchandise exports) in 1963?
Keep it short and to the point. 9.51. What is the difference between the highest and the lowest Imports(as % of merchandise exports) in 1964?
Your answer should be very brief. 9.67. What is the difference between the highest and the lowest Imports(as % of merchandise exports) in 1965?
Provide a short and direct response. 10. 